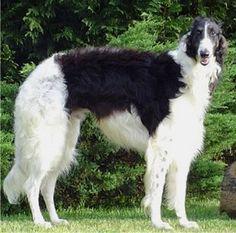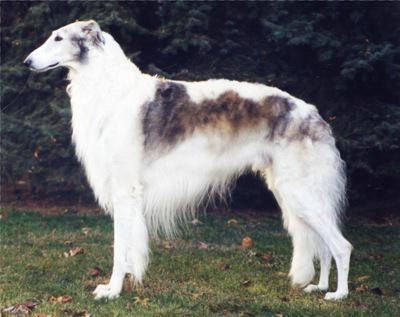The first image is the image on the left, the second image is the image on the right. Evaluate the accuracy of this statement regarding the images: "A single large dog is standing upright in each image.". Is it true? Answer yes or no. Yes. The first image is the image on the left, the second image is the image on the right. Analyze the images presented: Is the assertion "All images show one hound standing in profile on grass." valid? Answer yes or no. Yes. 